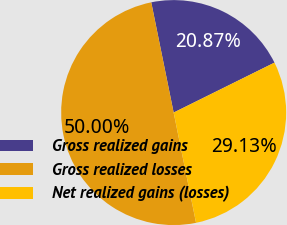Convert chart to OTSL. <chart><loc_0><loc_0><loc_500><loc_500><pie_chart><fcel>Gross realized gains<fcel>Gross realized losses<fcel>Net realized gains (losses)<nl><fcel>20.87%<fcel>50.0%<fcel>29.13%<nl></chart> 